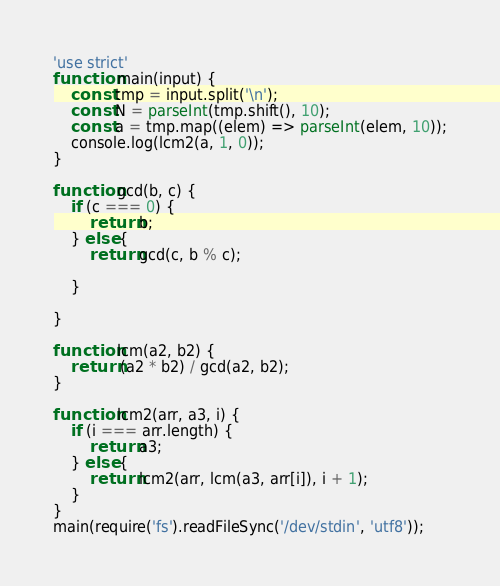Convert code to text. <code><loc_0><loc_0><loc_500><loc_500><_TypeScript_>'use strict'
function main(input) {
    const tmp = input.split('\n');
    const N = parseInt(tmp.shift(), 10);
    const a = tmp.map((elem) => parseInt(elem, 10));
    console.log(lcm2(a, 1, 0));
}

function gcd(b, c) {
    if (c === 0) {
        return b;
    } else {
        return gcd(c, b % c);

    }

}

function lcm(a2, b2) {
    return (a2 * b2) / gcd(a2, b2);
}

function lcm2(arr, a3, i) {
    if (i === arr.length) {
        return a3;
    } else {
        return lcm2(arr, lcm(a3, arr[i]), i + 1);
    }
}
main(require('fs').readFileSync('/dev/stdin', 'utf8'));</code> 